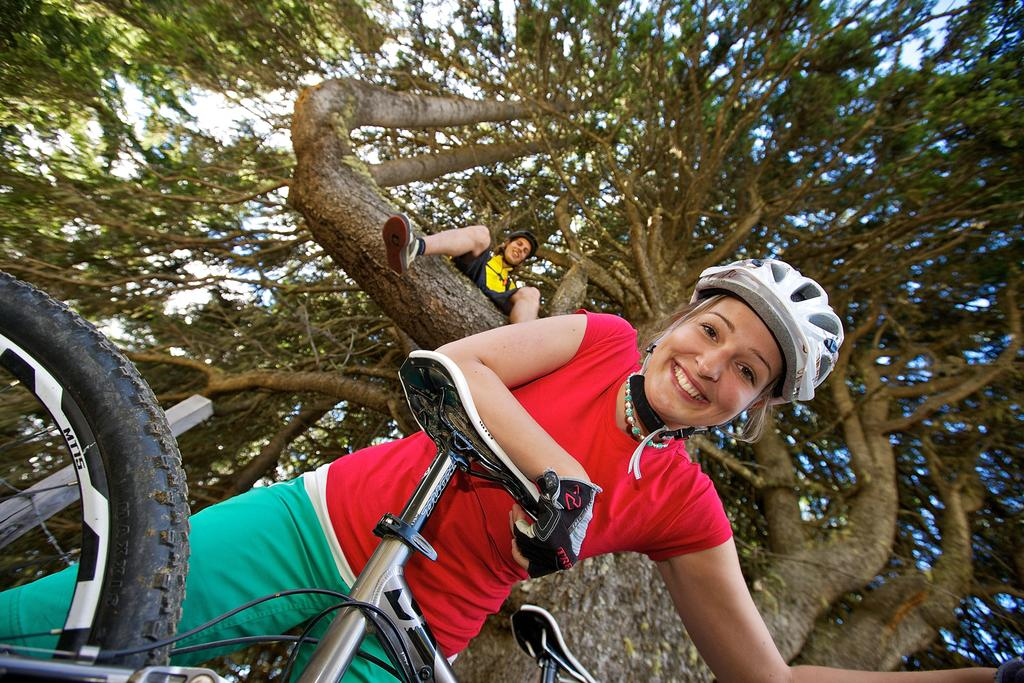How many people are in the picture? There are two people in the picture. What are the positions of the two people in the picture? One person is on a tree, and the other person is on the floor. What is the person on the floor holding? The person on the floor is holding a bicycle. What safety gear is the person on the floor wearing? The person on the floor is wearing a helmet and hand gloves. What does the caption on the picture say? There is no caption present in the image. Is the person on the tree crying in the image? There is no indication in the image that the person on the tree is crying. 